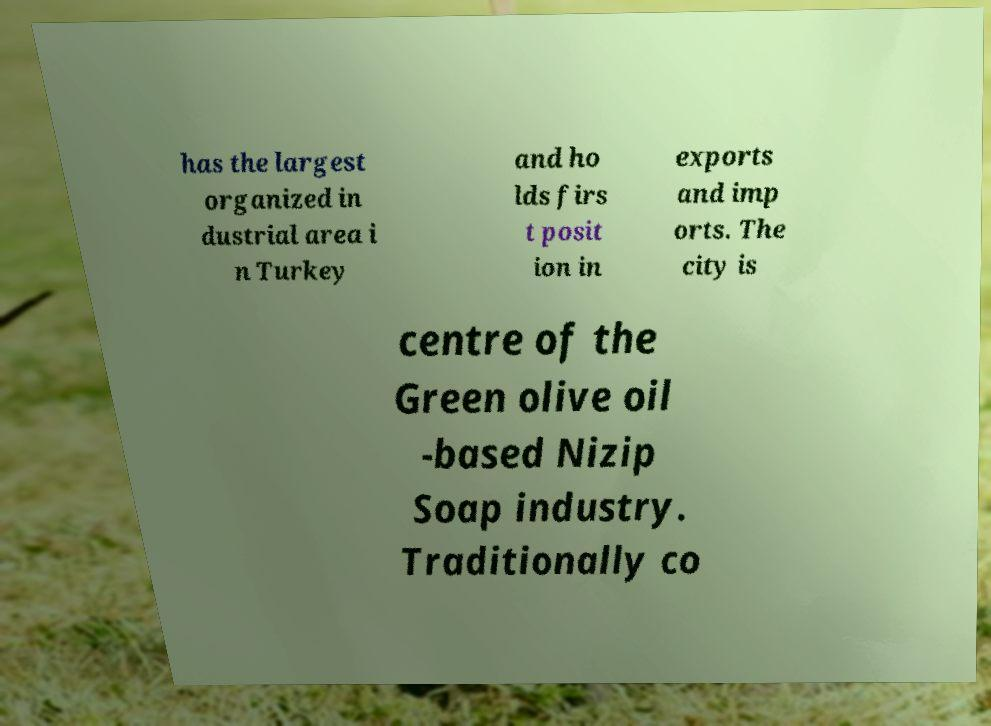I need the written content from this picture converted into text. Can you do that? has the largest organized in dustrial area i n Turkey and ho lds firs t posit ion in exports and imp orts. The city is centre of the Green olive oil -based Nizip Soap industry. Traditionally co 